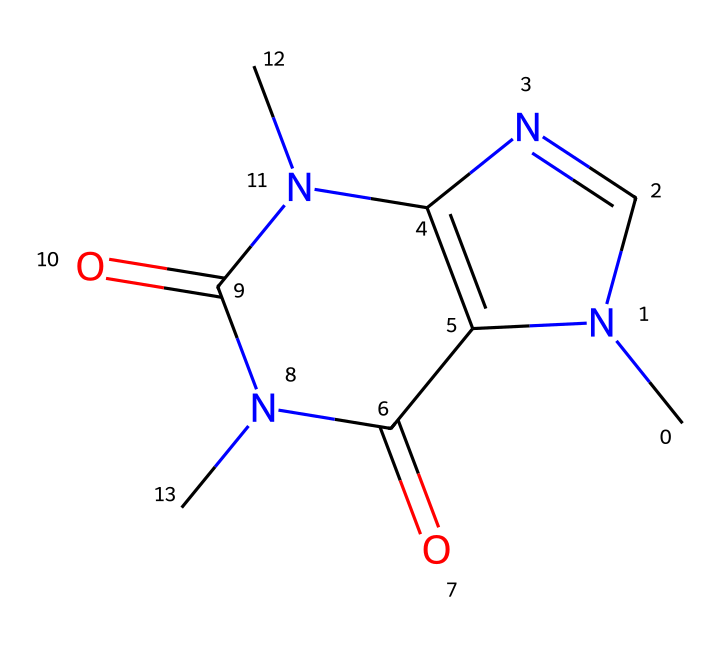how many carbons are in the caffeine structure? The SMILES representation can be analyzed to count the carbon atoms (C) present. Each 'C' in the SMILES refers to a carbon atom. By carefully counting, there are 8 carbon atoms in the structure.
Answer: eight what type of functional groups are present in caffeine? Upon examining the structure, there are carbonyl groups (indicated by the '=O') and amine groups (indicated by 'N'). Specifically, caffeine contains two carbonyl functional groups and one amine functional group.
Answer: carbonyl and amine what is the molecular formula of caffeine? To derive the molecular formula from the SMILES structure, we group the atoms. The analysis shows there are 8 carbon atoms, 10 hydrogen atoms, 4 nitrogen atoms, and 2 oxygen atoms, which leads to the molecular formula of C8H10N4O2.
Answer: C8H10N4O2 is caffeine a stimulant or depressant? Caffeine is well known for its stimulating effects on the central nervous system. This is closely linked to its molecular structure and how it interacts with adenosine receptors in the brain.
Answer: stimulant how many nitrogen atoms does caffeine contain? The structure of caffeine can be analyzed based on the nitrogen (N) present in the SMILES representation. By counting, we observe that there are four nitrogen atoms in total.
Answer: four what aspect of caffeine’s structure contributes to its solubility? The presence of polar functional groups such as the carbonyl and amine influences the solubility of caffeine in water. These polar groups allow interactions with water molecules, enhancing solubility.
Answer: polar functional groups 